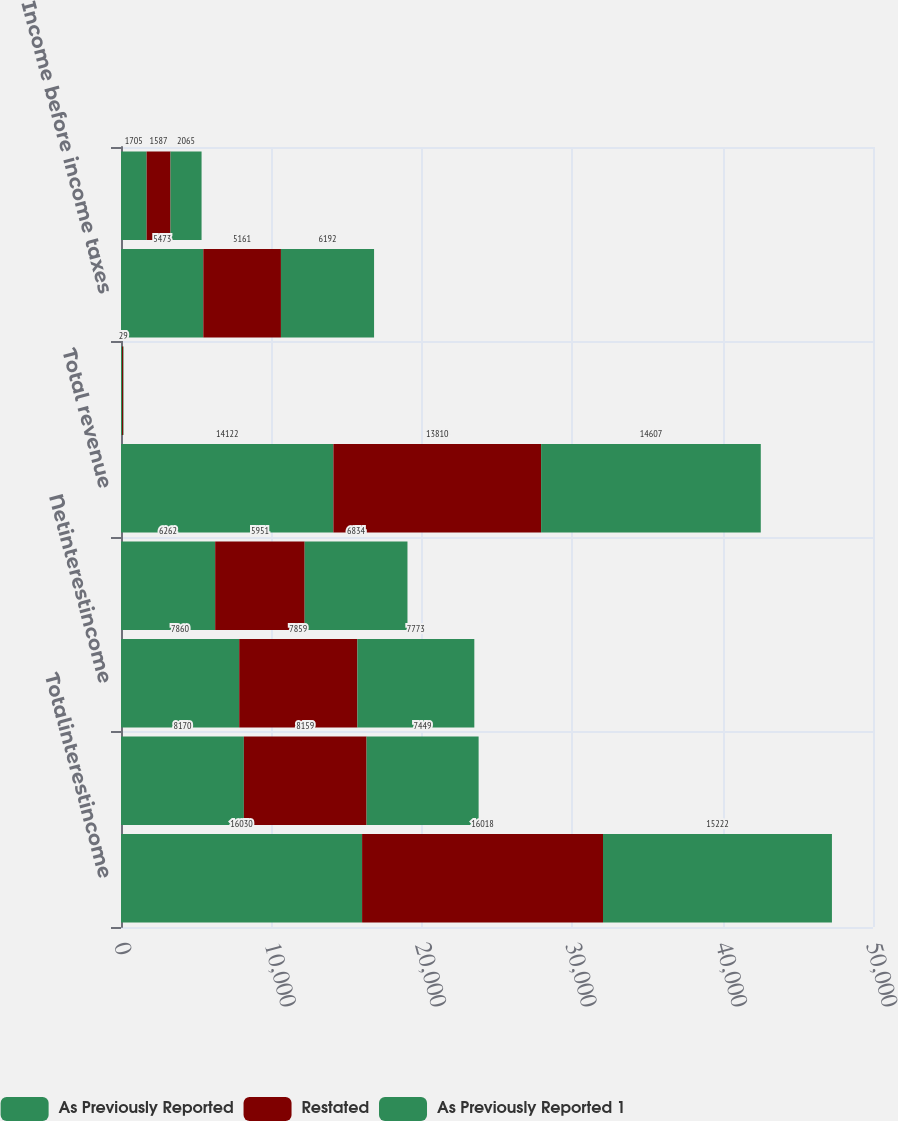<chart> <loc_0><loc_0><loc_500><loc_500><stacked_bar_chart><ecel><fcel>Totalinterestincome<fcel>Total interest expense<fcel>Netinterestincome<fcel>Total noninterest income<fcel>Total revenue<fcel>Gains on sales of debt<fcel>Income before income taxes<fcel>Income tax expense<nl><fcel>As Previously Reported<fcel>16030<fcel>8170<fcel>7860<fcel>6262<fcel>14122<fcel>71<fcel>5473<fcel>1705<nl><fcel>Restated<fcel>16018<fcel>8159<fcel>7859<fcel>5951<fcel>13810<fcel>71<fcel>5161<fcel>1587<nl><fcel>As Previously Reported 1<fcel>15222<fcel>7449<fcel>7773<fcel>6834<fcel>14607<fcel>29<fcel>6192<fcel>2065<nl></chart> 